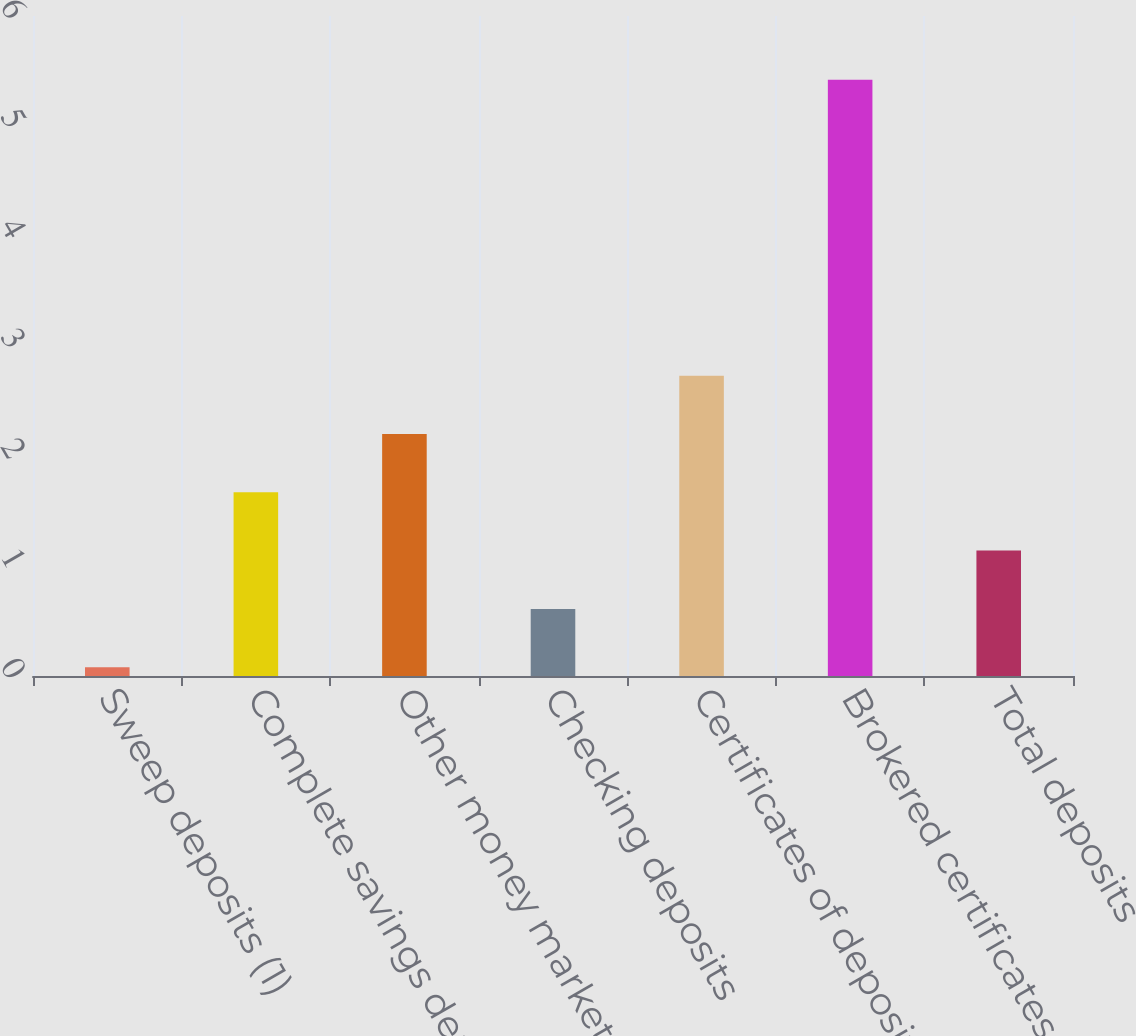Convert chart to OTSL. <chart><loc_0><loc_0><loc_500><loc_500><bar_chart><fcel>Sweep deposits (1)<fcel>Complete savings deposits<fcel>Other money market and savings<fcel>Checking deposits<fcel>Certificates of deposit<fcel>Brokered certificates of<fcel>Total deposits<nl><fcel>0.08<fcel>1.67<fcel>2.2<fcel>0.61<fcel>2.73<fcel>5.42<fcel>1.14<nl></chart> 